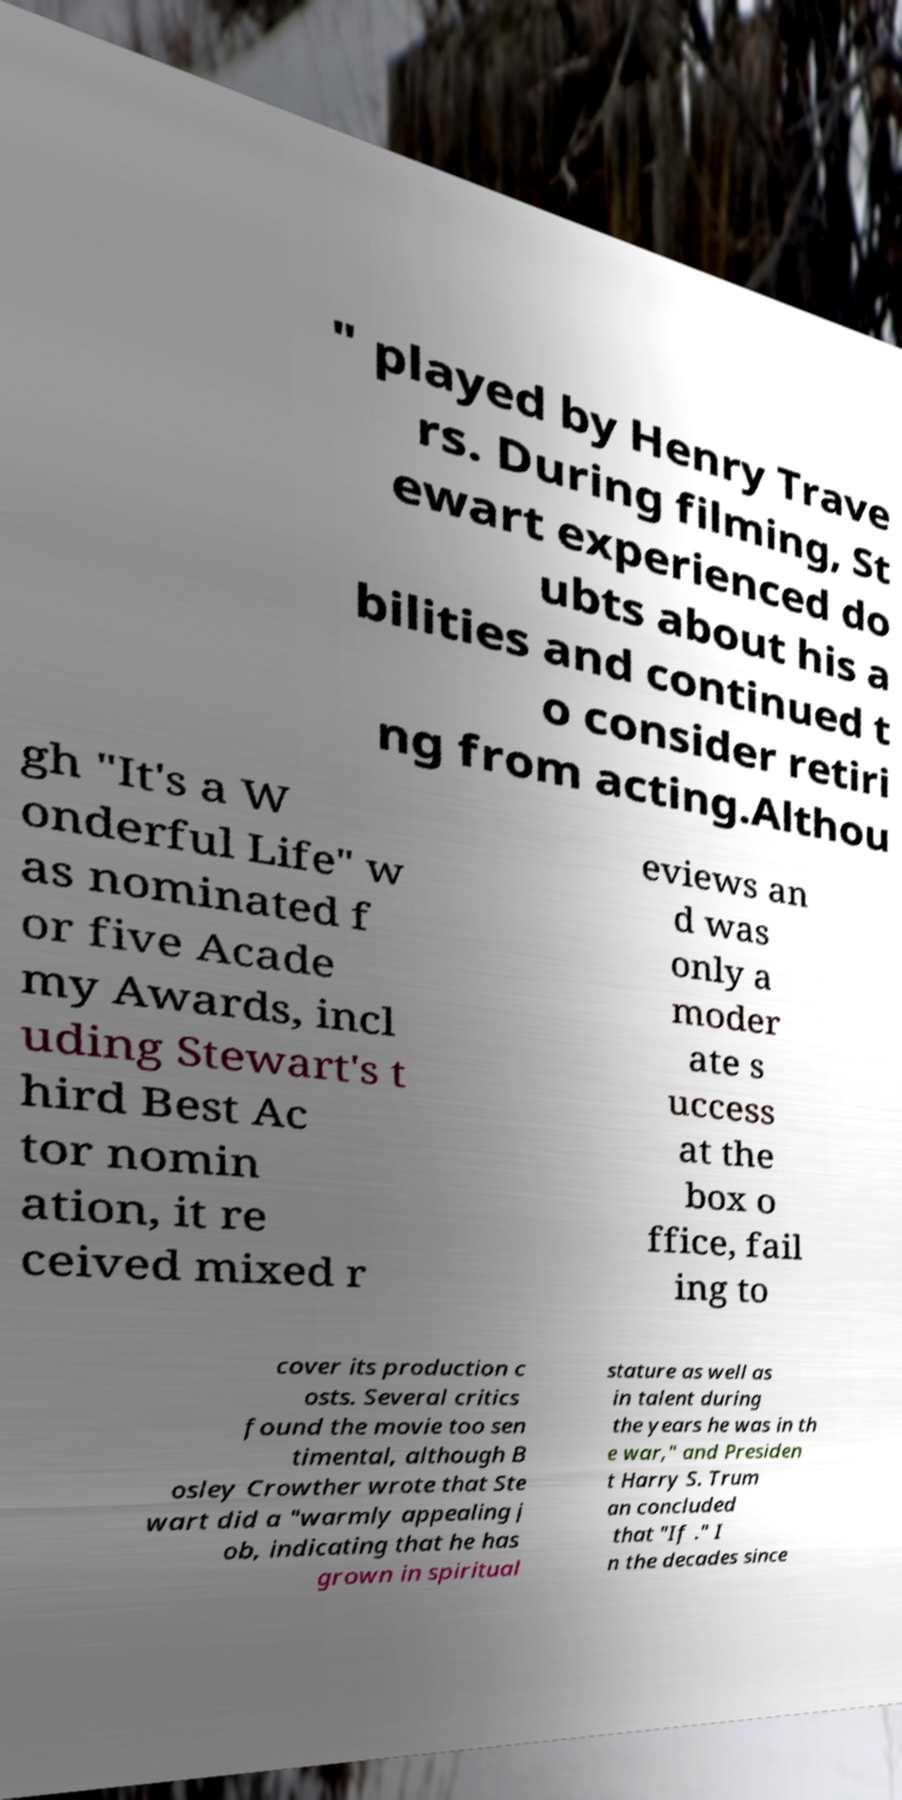Please read and relay the text visible in this image. What does it say? " played by Henry Trave rs. During filming, St ewart experienced do ubts about his a bilities and continued t o consider retiri ng from acting.Althou gh "It's a W onderful Life" w as nominated f or five Acade my Awards, incl uding Stewart's t hird Best Ac tor nomin ation, it re ceived mixed r eviews an d was only a moder ate s uccess at the box o ffice, fail ing to cover its production c osts. Several critics found the movie too sen timental, although B osley Crowther wrote that Ste wart did a "warmly appealing j ob, indicating that he has grown in spiritual stature as well as in talent during the years he was in th e war," and Presiden t Harry S. Trum an concluded that "If ." I n the decades since 